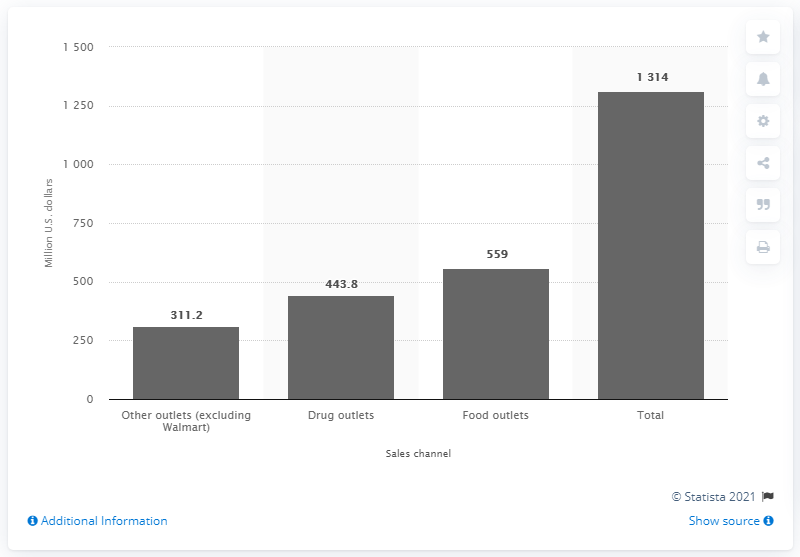Can you explain the trends in deodorant sales across different sales channels depicted in this chart? Certainly! The bar graph displays deodorant sales in millions of U.S. dollars for the year range 2011/2012, distributed across three sales channels: 'Other outlets (excluding Walmart)', 'Drug outlets', and 'Food outlets'. 'Other outlets' lead with the highest sales at $311.2 million, followed by 'Drug outlets' at $443.8 million, and 'Food outlets' with sales of $559 million. Overall, the total sales across all channels are $1,314 million, indicating a strong market for deodorant with distinctive consumer preferences according to retail channel. 